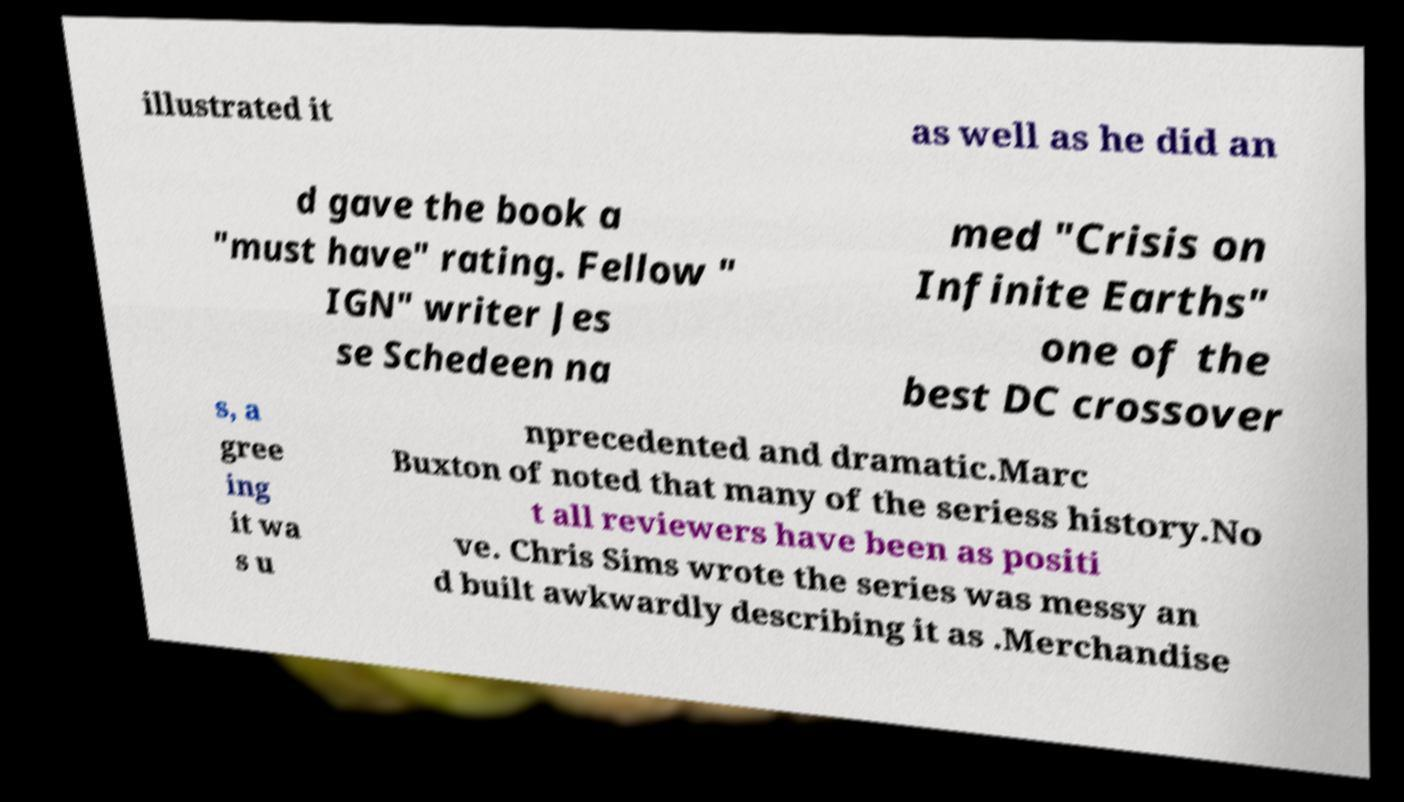Can you accurately transcribe the text from the provided image for me? illustrated it as well as he did an d gave the book a "must have" rating. Fellow " IGN" writer Jes se Schedeen na med "Crisis on Infinite Earths" one of the best DC crossover s, a gree ing it wa s u nprecedented and dramatic.Marc Buxton of noted that many of the seriess history.No t all reviewers have been as positi ve. Chris Sims wrote the series was messy an d built awkwardly describing it as .Merchandise 